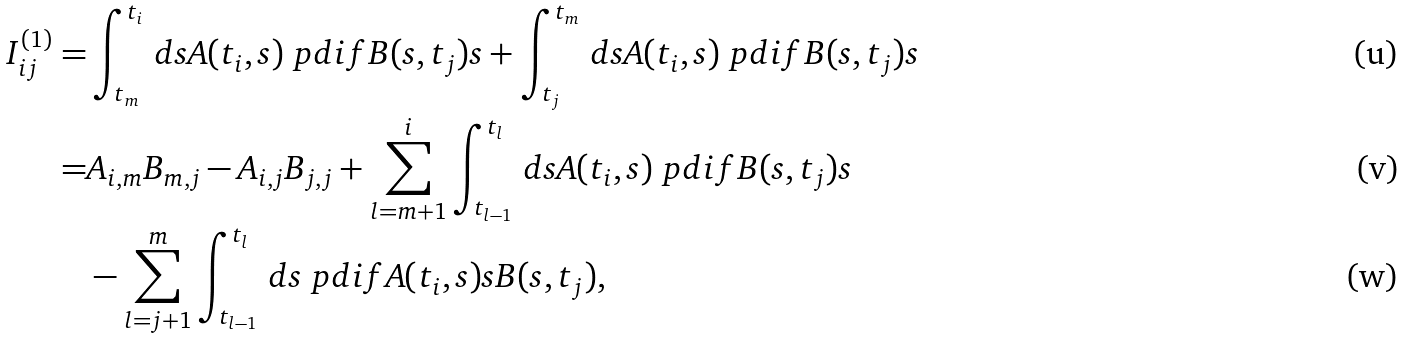Convert formula to latex. <formula><loc_0><loc_0><loc_500><loc_500>I ^ { ( 1 ) } _ { i j } = & \int _ { t _ { m } } ^ { t _ { i } } \, { d } s A ( t _ { i } , s ) \ p d i f { B ( s , t _ { j } ) } { s } + \int _ { t _ { j } } ^ { t _ { m } } \, { d } s A ( t _ { i } , s ) \ p d i f { B ( s , t _ { j } ) } { s } \\ = & A _ { i , m } B _ { m , j } - A _ { i , j } B _ { j , j } + \sum _ { l = m + 1 } ^ { i } \int _ { t _ { l - 1 } } ^ { t _ { l } } \, { d } s A ( t _ { i } , s ) \ p d i f { B ( s , t _ { j } ) } { s } \\ & - \sum _ { l = j + 1 } ^ { m } \int _ { t _ { l - 1 } } ^ { t _ { l } } \, { d } s \ p d i f { A ( t _ { i } , s ) } { s } B ( s , t _ { j } ) ,</formula> 